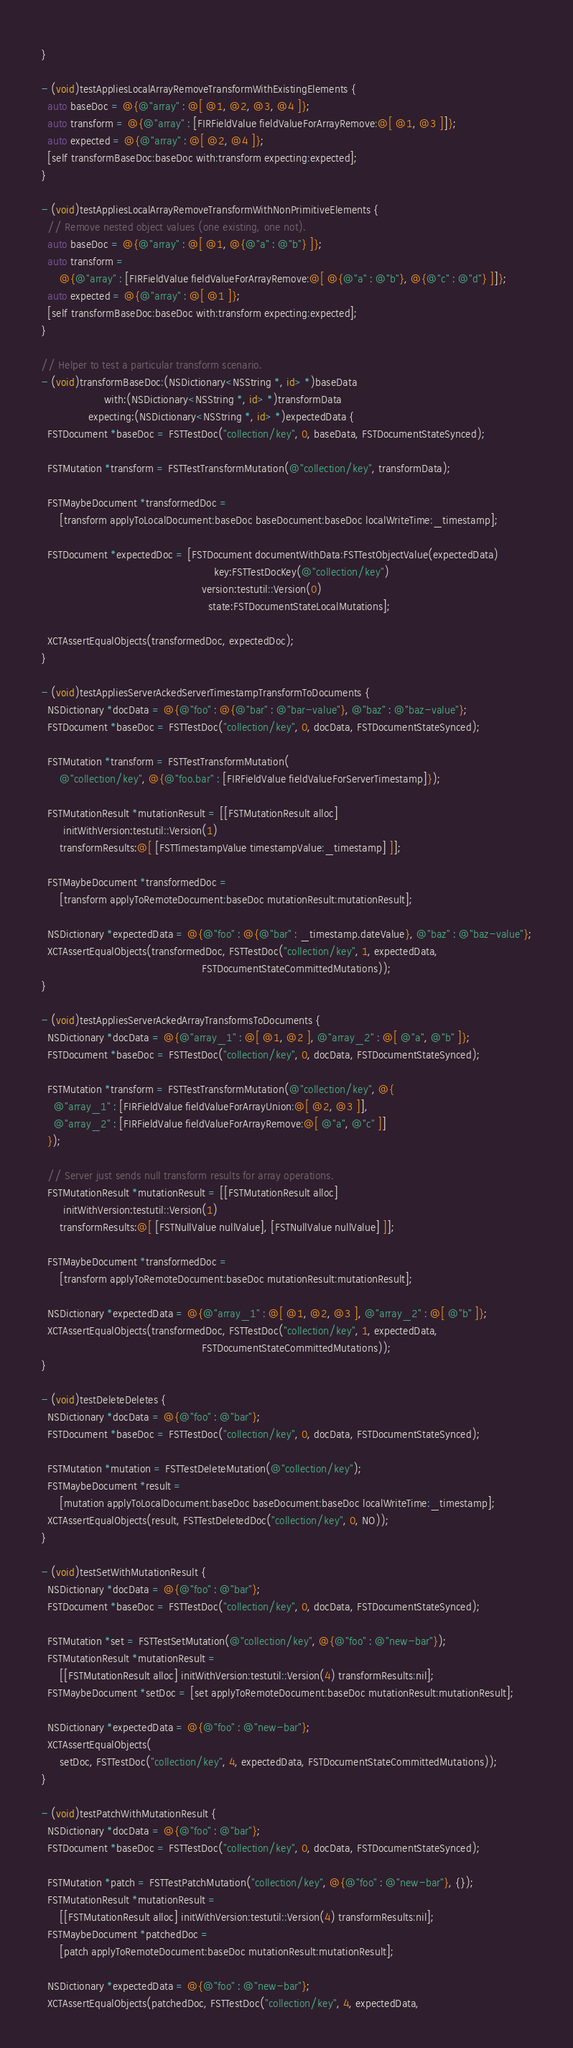<code> <loc_0><loc_0><loc_500><loc_500><_ObjectiveC_>}

- (void)testAppliesLocalArrayRemoveTransformWithExistingElements {
  auto baseDoc = @{@"array" : @[ @1, @2, @3, @4 ]};
  auto transform = @{@"array" : [FIRFieldValue fieldValueForArrayRemove:@[ @1, @3 ]]};
  auto expected = @{@"array" : @[ @2, @4 ]};
  [self transformBaseDoc:baseDoc with:transform expecting:expected];
}

- (void)testAppliesLocalArrayRemoveTransformWithNonPrimitiveElements {
  // Remove nested object values (one existing, one not).
  auto baseDoc = @{@"array" : @[ @1, @{@"a" : @"b"} ]};
  auto transform =
      @{@"array" : [FIRFieldValue fieldValueForArrayRemove:@[ @{@"a" : @"b"}, @{@"c" : @"d"} ]]};
  auto expected = @{@"array" : @[ @1 ]};
  [self transformBaseDoc:baseDoc with:transform expecting:expected];
}

// Helper to test a particular transform scenario.
- (void)transformBaseDoc:(NSDictionary<NSString *, id> *)baseData
                    with:(NSDictionary<NSString *, id> *)transformData
               expecting:(NSDictionary<NSString *, id> *)expectedData {
  FSTDocument *baseDoc = FSTTestDoc("collection/key", 0, baseData, FSTDocumentStateSynced);

  FSTMutation *transform = FSTTestTransformMutation(@"collection/key", transformData);

  FSTMaybeDocument *transformedDoc =
      [transform applyToLocalDocument:baseDoc baseDocument:baseDoc localWriteTime:_timestamp];

  FSTDocument *expectedDoc = [FSTDocument documentWithData:FSTTestObjectValue(expectedData)
                                                       key:FSTTestDocKey(@"collection/key")
                                                   version:testutil::Version(0)
                                                     state:FSTDocumentStateLocalMutations];

  XCTAssertEqualObjects(transformedDoc, expectedDoc);
}

- (void)testAppliesServerAckedServerTimestampTransformToDocuments {
  NSDictionary *docData = @{@"foo" : @{@"bar" : @"bar-value"}, @"baz" : @"baz-value"};
  FSTDocument *baseDoc = FSTTestDoc("collection/key", 0, docData, FSTDocumentStateSynced);

  FSTMutation *transform = FSTTestTransformMutation(
      @"collection/key", @{@"foo.bar" : [FIRFieldValue fieldValueForServerTimestamp]});

  FSTMutationResult *mutationResult = [[FSTMutationResult alloc]
       initWithVersion:testutil::Version(1)
      transformResults:@[ [FSTTimestampValue timestampValue:_timestamp] ]];

  FSTMaybeDocument *transformedDoc =
      [transform applyToRemoteDocument:baseDoc mutationResult:mutationResult];

  NSDictionary *expectedData = @{@"foo" : @{@"bar" : _timestamp.dateValue}, @"baz" : @"baz-value"};
  XCTAssertEqualObjects(transformedDoc, FSTTestDoc("collection/key", 1, expectedData,
                                                   FSTDocumentStateCommittedMutations));
}

- (void)testAppliesServerAckedArrayTransformsToDocuments {
  NSDictionary *docData = @{@"array_1" : @[ @1, @2 ], @"array_2" : @[ @"a", @"b" ]};
  FSTDocument *baseDoc = FSTTestDoc("collection/key", 0, docData, FSTDocumentStateSynced);

  FSTMutation *transform = FSTTestTransformMutation(@"collection/key", @{
    @"array_1" : [FIRFieldValue fieldValueForArrayUnion:@[ @2, @3 ]],
    @"array_2" : [FIRFieldValue fieldValueForArrayRemove:@[ @"a", @"c" ]]
  });

  // Server just sends null transform results for array operations.
  FSTMutationResult *mutationResult = [[FSTMutationResult alloc]
       initWithVersion:testutil::Version(1)
      transformResults:@[ [FSTNullValue nullValue], [FSTNullValue nullValue] ]];

  FSTMaybeDocument *transformedDoc =
      [transform applyToRemoteDocument:baseDoc mutationResult:mutationResult];

  NSDictionary *expectedData = @{@"array_1" : @[ @1, @2, @3 ], @"array_2" : @[ @"b" ]};
  XCTAssertEqualObjects(transformedDoc, FSTTestDoc("collection/key", 1, expectedData,
                                                   FSTDocumentStateCommittedMutations));
}

- (void)testDeleteDeletes {
  NSDictionary *docData = @{@"foo" : @"bar"};
  FSTDocument *baseDoc = FSTTestDoc("collection/key", 0, docData, FSTDocumentStateSynced);

  FSTMutation *mutation = FSTTestDeleteMutation(@"collection/key");
  FSTMaybeDocument *result =
      [mutation applyToLocalDocument:baseDoc baseDocument:baseDoc localWriteTime:_timestamp];
  XCTAssertEqualObjects(result, FSTTestDeletedDoc("collection/key", 0, NO));
}

- (void)testSetWithMutationResult {
  NSDictionary *docData = @{@"foo" : @"bar"};
  FSTDocument *baseDoc = FSTTestDoc("collection/key", 0, docData, FSTDocumentStateSynced);

  FSTMutation *set = FSTTestSetMutation(@"collection/key", @{@"foo" : @"new-bar"});
  FSTMutationResult *mutationResult =
      [[FSTMutationResult alloc] initWithVersion:testutil::Version(4) transformResults:nil];
  FSTMaybeDocument *setDoc = [set applyToRemoteDocument:baseDoc mutationResult:mutationResult];

  NSDictionary *expectedData = @{@"foo" : @"new-bar"};
  XCTAssertEqualObjects(
      setDoc, FSTTestDoc("collection/key", 4, expectedData, FSTDocumentStateCommittedMutations));
}

- (void)testPatchWithMutationResult {
  NSDictionary *docData = @{@"foo" : @"bar"};
  FSTDocument *baseDoc = FSTTestDoc("collection/key", 0, docData, FSTDocumentStateSynced);

  FSTMutation *patch = FSTTestPatchMutation("collection/key", @{@"foo" : @"new-bar"}, {});
  FSTMutationResult *mutationResult =
      [[FSTMutationResult alloc] initWithVersion:testutil::Version(4) transformResults:nil];
  FSTMaybeDocument *patchedDoc =
      [patch applyToRemoteDocument:baseDoc mutationResult:mutationResult];

  NSDictionary *expectedData = @{@"foo" : @"new-bar"};
  XCTAssertEqualObjects(patchedDoc, FSTTestDoc("collection/key", 4, expectedData,</code> 